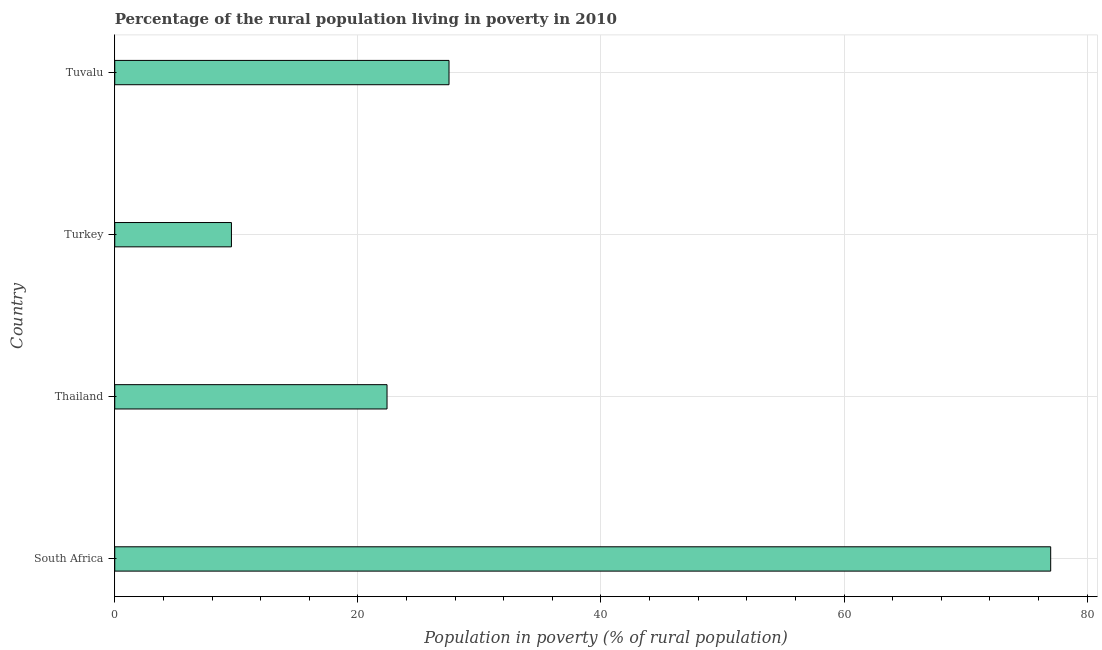Does the graph contain any zero values?
Offer a very short reply. No. What is the title of the graph?
Make the answer very short. Percentage of the rural population living in poverty in 2010. What is the label or title of the X-axis?
Your answer should be compact. Population in poverty (% of rural population). What is the label or title of the Y-axis?
Offer a terse response. Country. Across all countries, what is the maximum percentage of rural population living below poverty line?
Your answer should be compact. 77. Across all countries, what is the minimum percentage of rural population living below poverty line?
Ensure brevity in your answer.  9.6. In which country was the percentage of rural population living below poverty line maximum?
Give a very brief answer. South Africa. What is the sum of the percentage of rural population living below poverty line?
Provide a succinct answer. 136.5. What is the difference between the percentage of rural population living below poverty line in Turkey and Tuvalu?
Offer a terse response. -17.9. What is the average percentage of rural population living below poverty line per country?
Your answer should be compact. 34.12. What is the median percentage of rural population living below poverty line?
Give a very brief answer. 24.95. In how many countries, is the percentage of rural population living below poverty line greater than 12 %?
Your answer should be compact. 3. What is the ratio of the percentage of rural population living below poverty line in Turkey to that in Tuvalu?
Give a very brief answer. 0.35. What is the difference between the highest and the second highest percentage of rural population living below poverty line?
Your answer should be very brief. 49.5. What is the difference between the highest and the lowest percentage of rural population living below poverty line?
Provide a short and direct response. 67.4. How many bars are there?
Keep it short and to the point. 4. What is the Population in poverty (% of rural population) in Thailand?
Offer a terse response. 22.4. What is the Population in poverty (% of rural population) of Tuvalu?
Your answer should be very brief. 27.5. What is the difference between the Population in poverty (% of rural population) in South Africa and Thailand?
Your answer should be compact. 54.6. What is the difference between the Population in poverty (% of rural population) in South Africa and Turkey?
Keep it short and to the point. 67.4. What is the difference between the Population in poverty (% of rural population) in South Africa and Tuvalu?
Give a very brief answer. 49.5. What is the difference between the Population in poverty (% of rural population) in Thailand and Tuvalu?
Provide a succinct answer. -5.1. What is the difference between the Population in poverty (% of rural population) in Turkey and Tuvalu?
Your answer should be very brief. -17.9. What is the ratio of the Population in poverty (% of rural population) in South Africa to that in Thailand?
Ensure brevity in your answer.  3.44. What is the ratio of the Population in poverty (% of rural population) in South Africa to that in Turkey?
Keep it short and to the point. 8.02. What is the ratio of the Population in poverty (% of rural population) in South Africa to that in Tuvalu?
Make the answer very short. 2.8. What is the ratio of the Population in poverty (% of rural population) in Thailand to that in Turkey?
Your answer should be very brief. 2.33. What is the ratio of the Population in poverty (% of rural population) in Thailand to that in Tuvalu?
Give a very brief answer. 0.81. What is the ratio of the Population in poverty (% of rural population) in Turkey to that in Tuvalu?
Offer a very short reply. 0.35. 